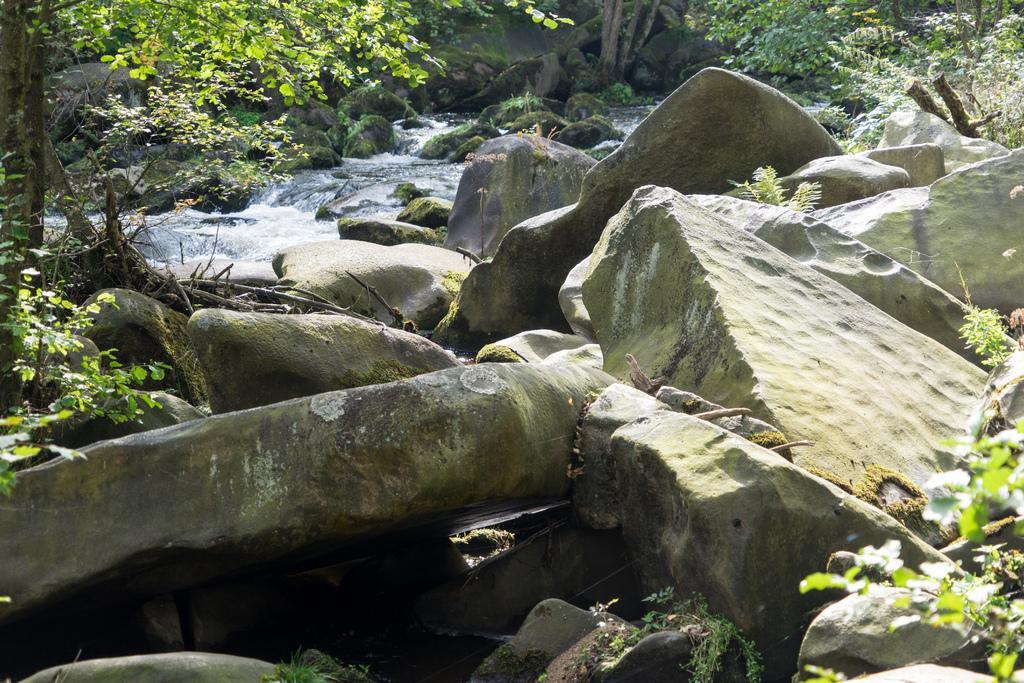Please provide a concise description of this image. In this image we can see there are rocks and trees. In the middle of the rocks there are some water and some algae on the rocks. 